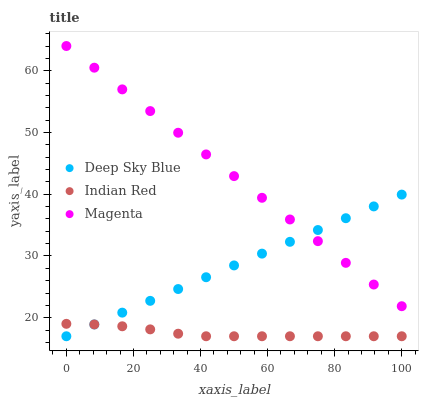Does Indian Red have the minimum area under the curve?
Answer yes or no. Yes. Does Magenta have the maximum area under the curve?
Answer yes or no. Yes. Does Deep Sky Blue have the minimum area under the curve?
Answer yes or no. No. Does Deep Sky Blue have the maximum area under the curve?
Answer yes or no. No. Is Deep Sky Blue the smoothest?
Answer yes or no. Yes. Is Indian Red the roughest?
Answer yes or no. Yes. Is Indian Red the smoothest?
Answer yes or no. No. Is Deep Sky Blue the roughest?
Answer yes or no. No. Does Indian Red have the lowest value?
Answer yes or no. Yes. Does Magenta have the highest value?
Answer yes or no. Yes. Does Deep Sky Blue have the highest value?
Answer yes or no. No. Is Indian Red less than Magenta?
Answer yes or no. Yes. Is Magenta greater than Indian Red?
Answer yes or no. Yes. Does Deep Sky Blue intersect Magenta?
Answer yes or no. Yes. Is Deep Sky Blue less than Magenta?
Answer yes or no. No. Is Deep Sky Blue greater than Magenta?
Answer yes or no. No. Does Indian Red intersect Magenta?
Answer yes or no. No. 